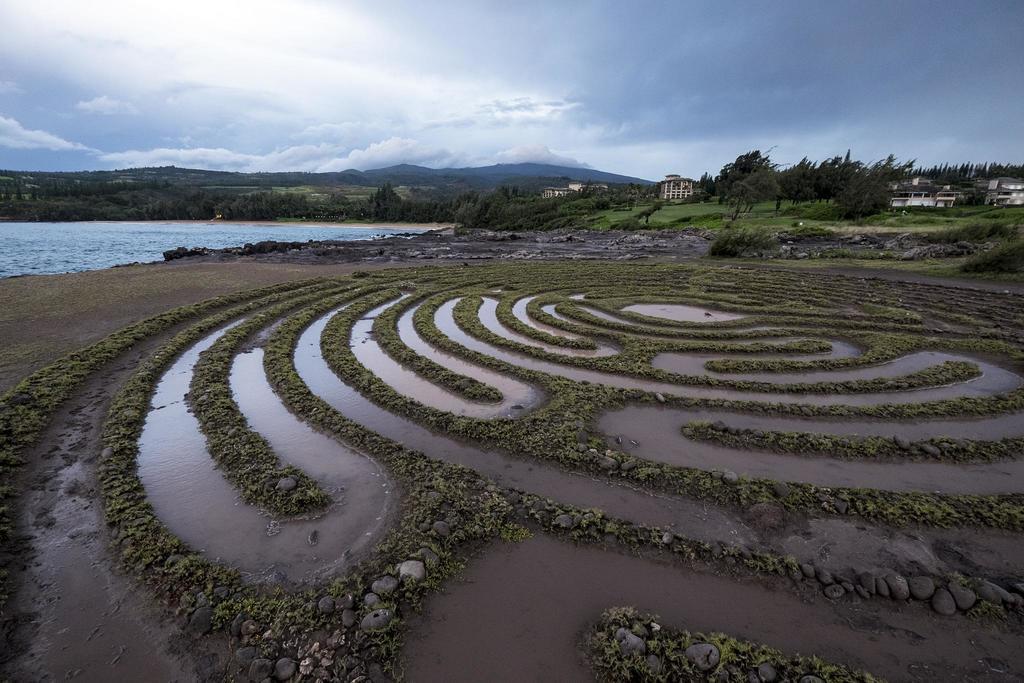Please provide a concise description of this image. In this image, we can see trees, buildings and there are hills. At the top, there are clouds in the sky and at the bottom, there is water and we can see rocks, stones and there is ground. 